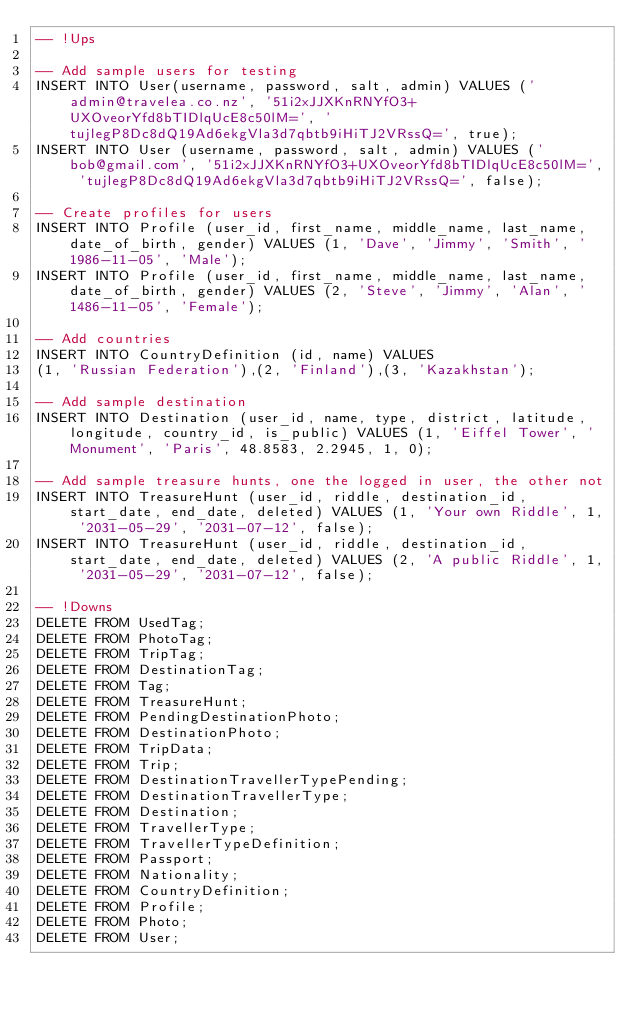<code> <loc_0><loc_0><loc_500><loc_500><_SQL_>-- !Ups

-- Add sample users for testing
INSERT INTO User(username, password, salt, admin) VALUES ('admin@travelea.co.nz', '51i2xJJXKnRNYfO3+UXOveorYfd8bTIDlqUcE8c50lM=', 'tujlegP8Dc8dQ19Ad6ekgVla3d7qbtb9iHiTJ2VRssQ=', true);
INSERT INTO User (username, password, salt, admin) VALUES ('bob@gmail.com', '51i2xJJXKnRNYfO3+UXOveorYfd8bTIDlqUcE8c50lM=', 'tujlegP8Dc8dQ19Ad6ekgVla3d7qbtb9iHiTJ2VRssQ=', false);

-- Create profiles for users
INSERT INTO Profile (user_id, first_name, middle_name, last_name, date_of_birth, gender) VALUES (1, 'Dave', 'Jimmy', 'Smith', '1986-11-05', 'Male');
INSERT INTO Profile (user_id, first_name, middle_name, last_name, date_of_birth, gender) VALUES (2, 'Steve', 'Jimmy', 'Alan', '1486-11-05', 'Female');

-- Add countries
INSERT INTO CountryDefinition (id, name) VALUES
(1, 'Russian Federation'),(2, 'Finland'),(3, 'Kazakhstan');

-- Add sample destination
INSERT INTO Destination (user_id, name, type, district, latitude, longitude, country_id, is_public) VALUES (1, 'Eiffel Tower', 'Monument', 'Paris', 48.8583, 2.2945, 1, 0);

-- Add sample treasure hunts, one the logged in user, the other not
INSERT INTO TreasureHunt (user_id, riddle, destination_id, start_date, end_date, deleted) VALUES (1, 'Your own Riddle', 1, '2031-05-29', '2031-07-12', false);
INSERT INTO TreasureHunt (user_id, riddle, destination_id, start_date, end_date, deleted) VALUES (2, 'A public Riddle', 1, '2031-05-29', '2031-07-12', false);

-- !Downs
DELETE FROM UsedTag;
DELETE FROM PhotoTag;
DELETE FROM TripTag;
DELETE FROM DestinationTag;
DELETE FROM Tag;
DELETE FROM TreasureHunt;
DELETE FROM PendingDestinationPhoto;
DELETE FROM DestinationPhoto;
DELETE FROM TripData;
DELETE FROM Trip;
DELETE FROM DestinationTravellerTypePending;
DELETE FROM DestinationTravellerType;
DELETE FROM Destination;
DELETE FROM TravellerType;
DELETE FROM TravellerTypeDefinition;
DELETE FROM Passport;
DELETE FROM Nationality;
DELETE FROM CountryDefinition;
DELETE FROM Profile;
DELETE FROM Photo;
DELETE FROM User;</code> 